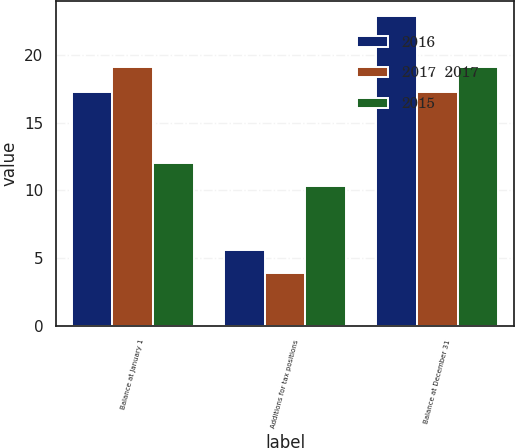Convert chart to OTSL. <chart><loc_0><loc_0><loc_500><loc_500><stacked_bar_chart><ecel><fcel>Balance at January 1<fcel>Additions for tax positions<fcel>Balance at December 31<nl><fcel>2016<fcel>17.3<fcel>5.6<fcel>22.9<nl><fcel>2017  2017<fcel>19.1<fcel>3.9<fcel>17.3<nl><fcel>2015<fcel>12<fcel>10.3<fcel>19.1<nl></chart> 